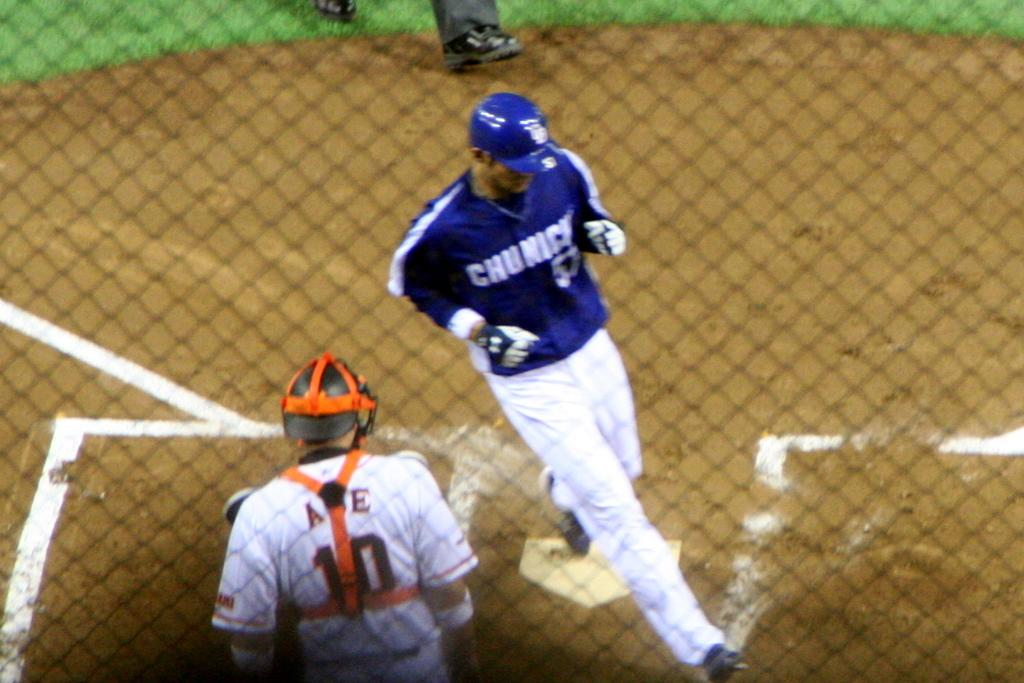<image>
Share a concise interpretation of the image provided. Baseball player wearing a blue jersey that says Chunicks. 